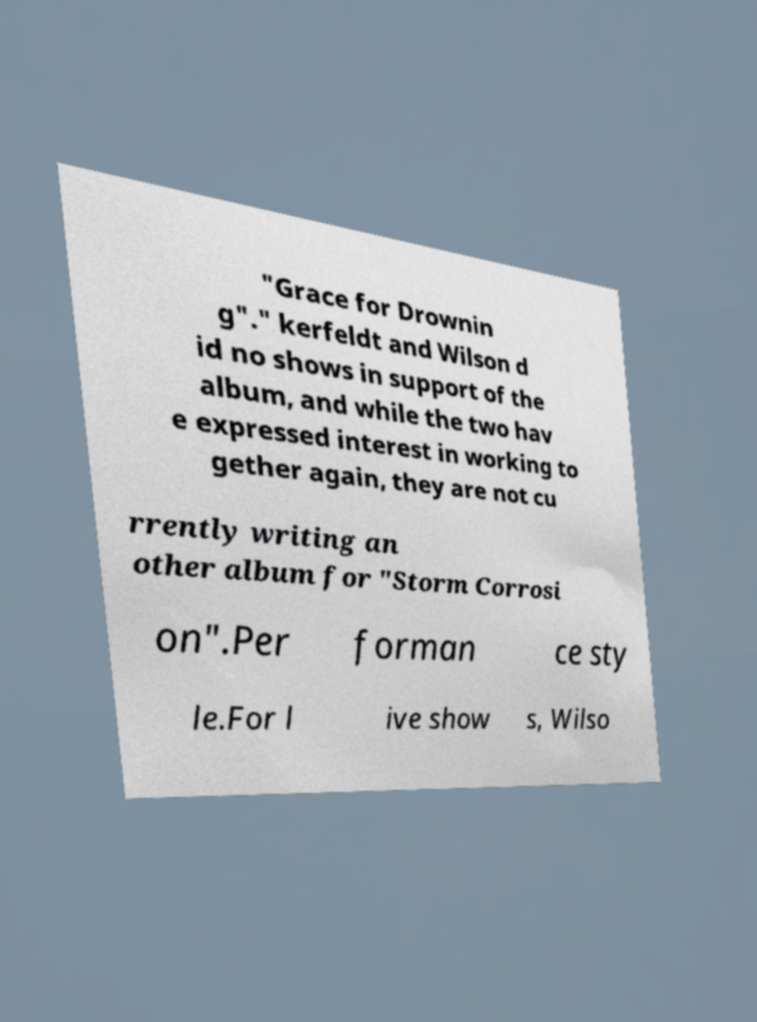For documentation purposes, I need the text within this image transcribed. Could you provide that? "Grace for Drownin g"." kerfeldt and Wilson d id no shows in support of the album, and while the two hav e expressed interest in working to gether again, they are not cu rrently writing an other album for "Storm Corrosi on".Per forman ce sty le.For l ive show s, Wilso 